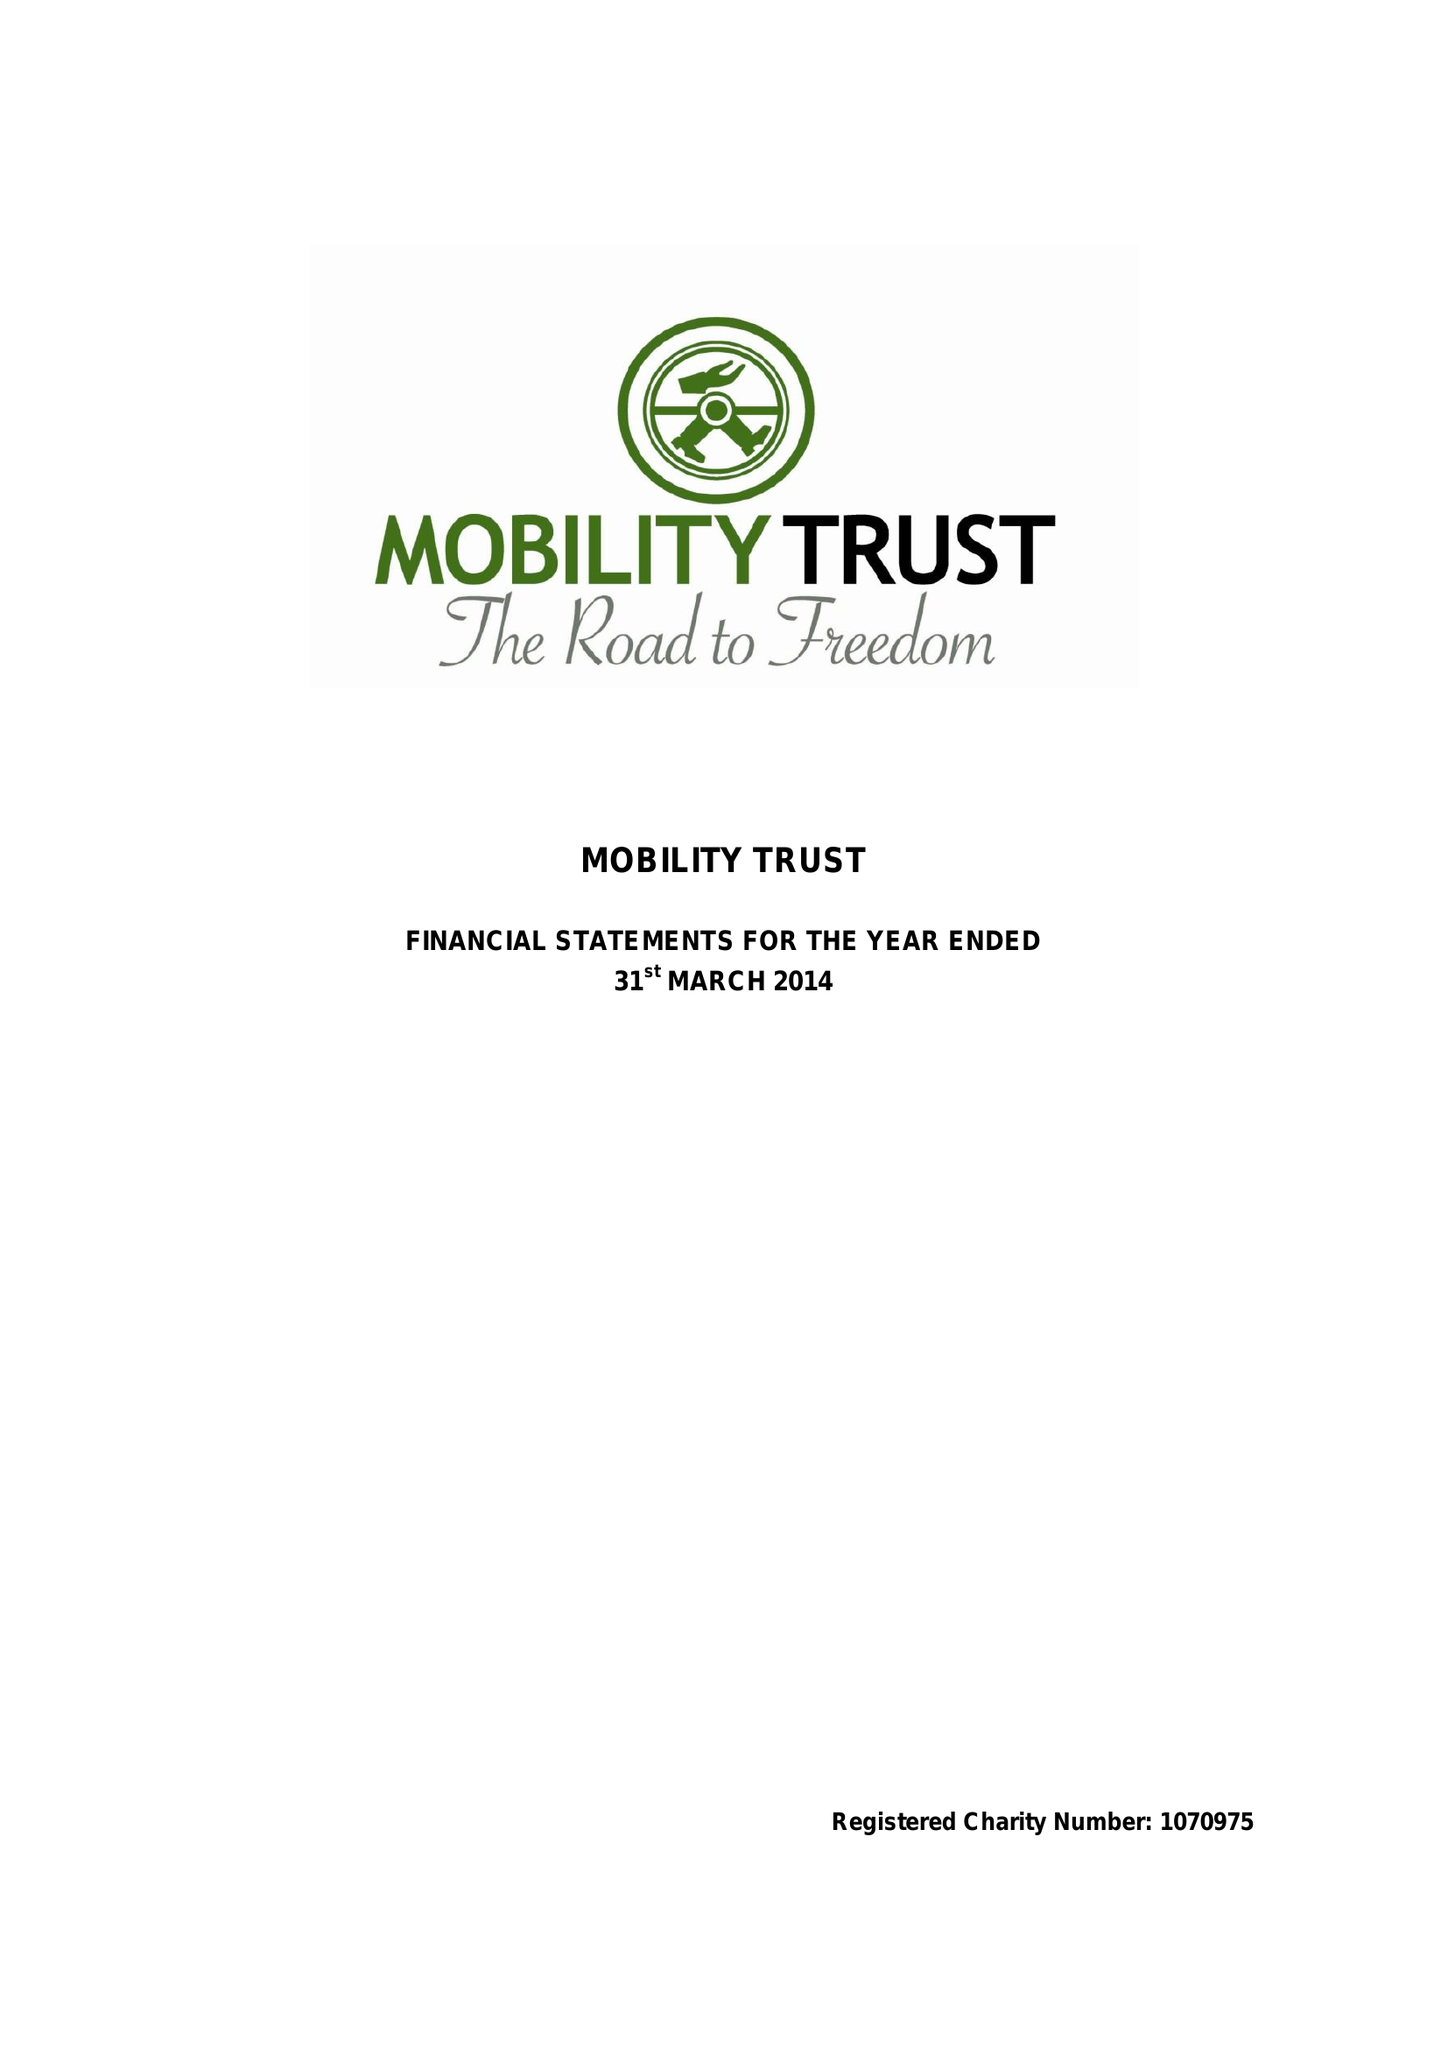What is the value for the charity_number?
Answer the question using a single word or phrase. 1070975 